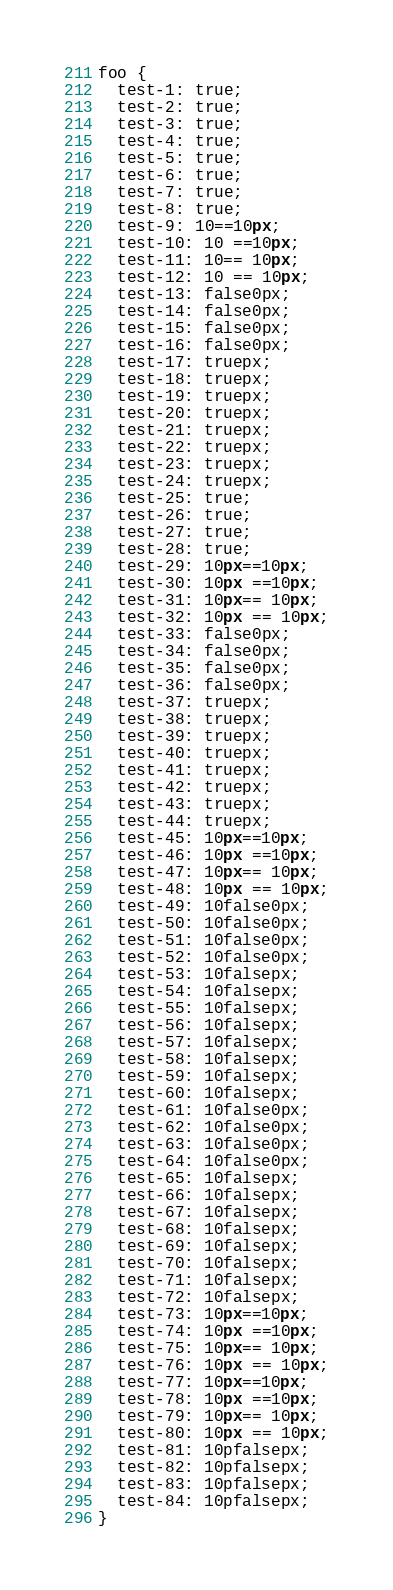<code> <loc_0><loc_0><loc_500><loc_500><_CSS_>foo {
  test-1: true;
  test-2: true;
  test-3: true;
  test-4: true;
  test-5: true;
  test-6: true;
  test-7: true;
  test-8: true;
  test-9: 10==10px;
  test-10: 10 ==10px;
  test-11: 10== 10px;
  test-12: 10 == 10px;
  test-13: false0px;
  test-14: false0px;
  test-15: false0px;
  test-16: false0px;
  test-17: truepx;
  test-18: truepx;
  test-19: truepx;
  test-20: truepx;
  test-21: truepx;
  test-22: truepx;
  test-23: truepx;
  test-24: truepx;
  test-25: true;
  test-26: true;
  test-27: true;
  test-28: true;
  test-29: 10px==10px;
  test-30: 10px ==10px;
  test-31: 10px== 10px;
  test-32: 10px == 10px;
  test-33: false0px;
  test-34: false0px;
  test-35: false0px;
  test-36: false0px;
  test-37: truepx;
  test-38: truepx;
  test-39: truepx;
  test-40: truepx;
  test-41: truepx;
  test-42: truepx;
  test-43: truepx;
  test-44: truepx;
  test-45: 10px==10px;
  test-46: 10px ==10px;
  test-47: 10px== 10px;
  test-48: 10px == 10px;
  test-49: 10false0px;
  test-50: 10false0px;
  test-51: 10false0px;
  test-52: 10false0px;
  test-53: 10falsepx;
  test-54: 10falsepx;
  test-55: 10falsepx;
  test-56: 10falsepx;
  test-57: 10falsepx;
  test-58: 10falsepx;
  test-59: 10falsepx;
  test-60: 10falsepx;
  test-61: 10false0px;
  test-62: 10false0px;
  test-63: 10false0px;
  test-64: 10false0px;
  test-65: 10falsepx;
  test-66: 10falsepx;
  test-67: 10falsepx;
  test-68: 10falsepx;
  test-69: 10falsepx;
  test-70: 10falsepx;
  test-71: 10falsepx;
  test-72: 10falsepx;
  test-73: 10px==10px;
  test-74: 10px ==10px;
  test-75: 10px== 10px;
  test-76: 10px == 10px;
  test-77: 10px==10px;
  test-78: 10px ==10px;
  test-79: 10px== 10px;
  test-80: 10px == 10px;
  test-81: 10pfalsepx;
  test-82: 10pfalsepx;
  test-83: 10pfalsepx;
  test-84: 10pfalsepx;
}
</code> 